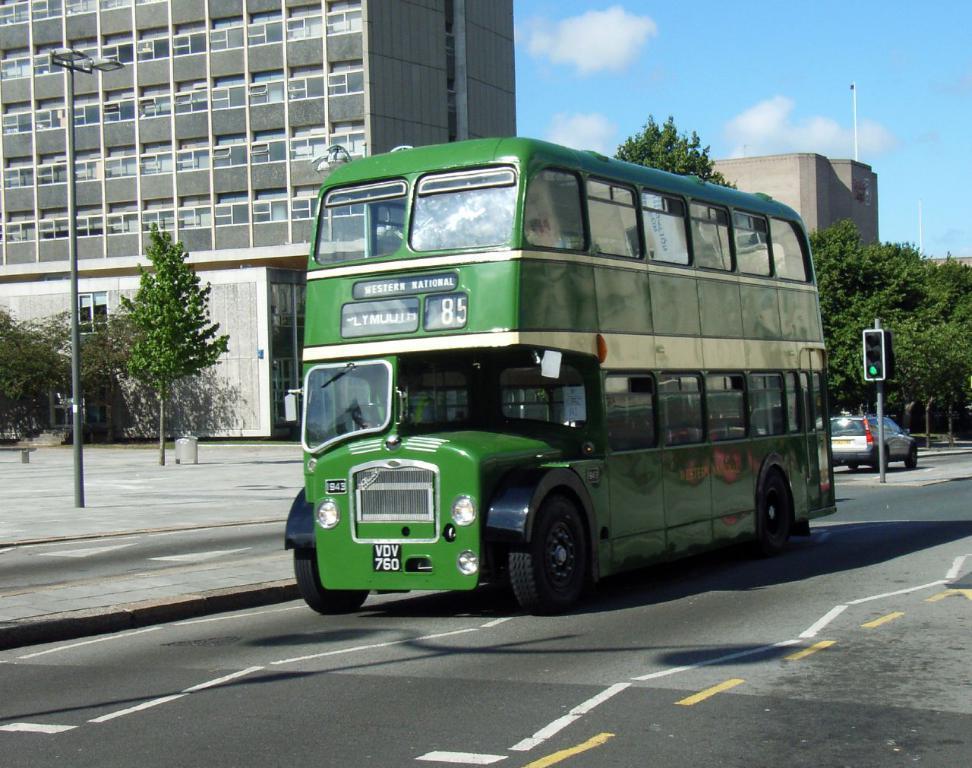Can you describe this image briefly? This image consists of a bus in green color. At the bottom, there is a road. In the background, there are buildings. To the right, there are trees. 